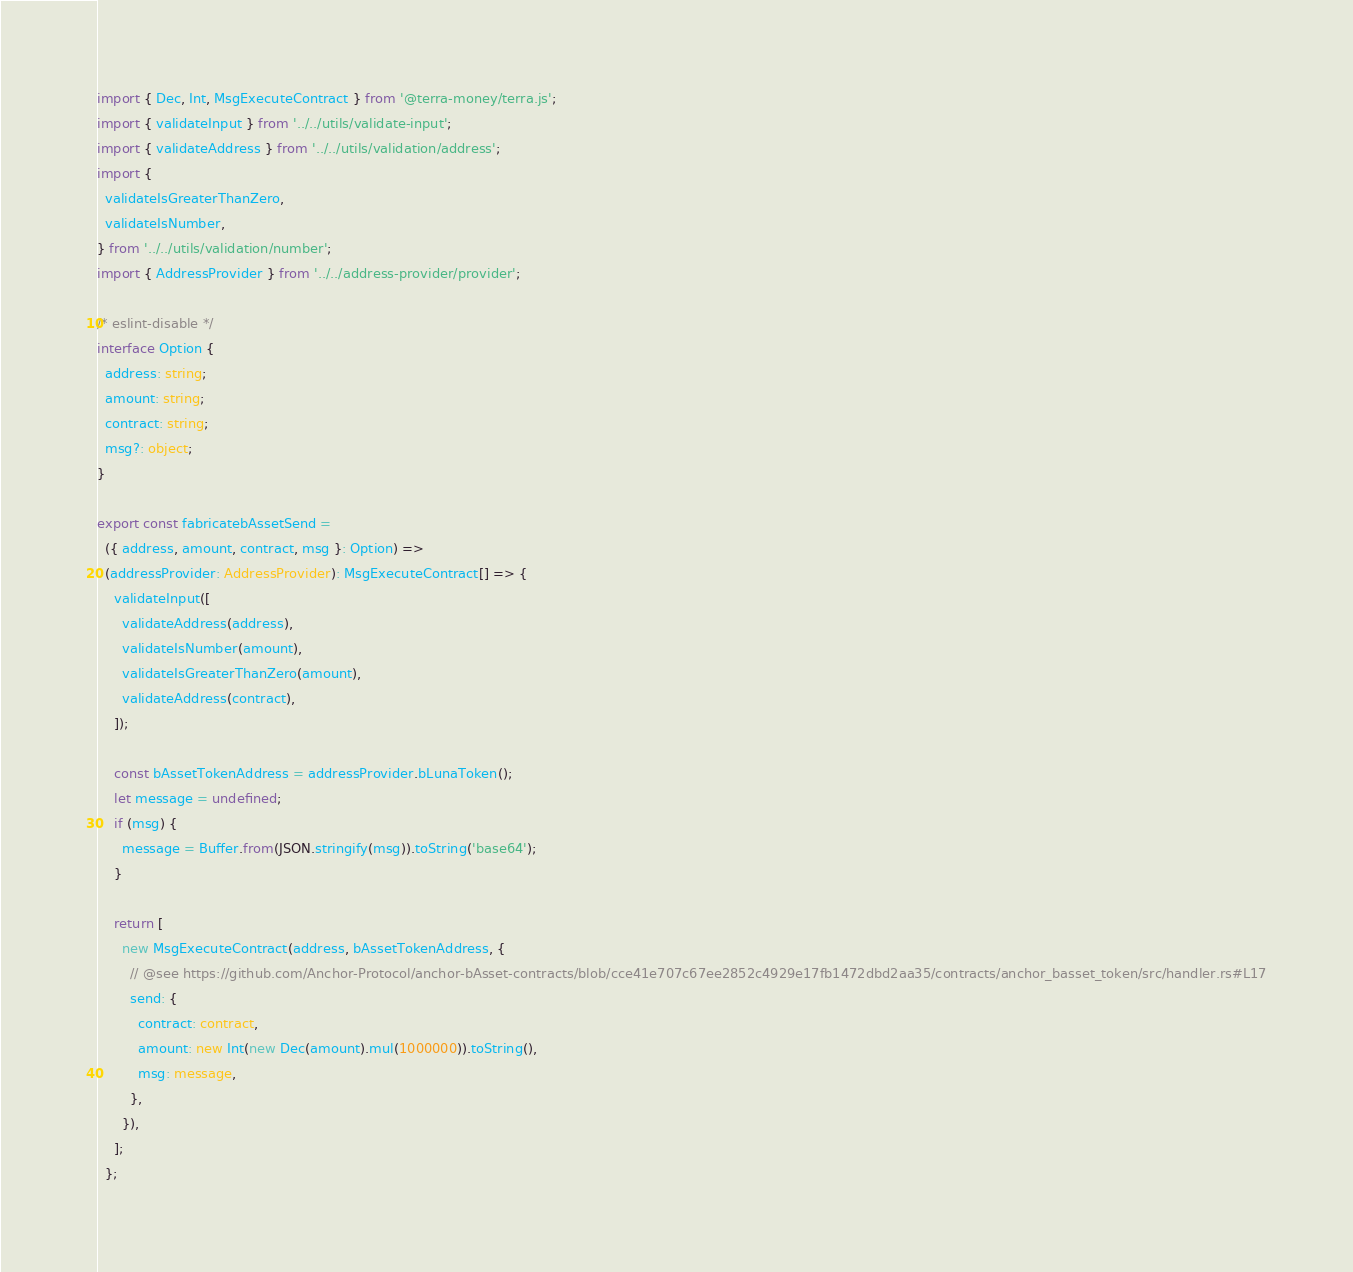Convert code to text. <code><loc_0><loc_0><loc_500><loc_500><_TypeScript_>import { Dec, Int, MsgExecuteContract } from '@terra-money/terra.js';
import { validateInput } from '../../utils/validate-input';
import { validateAddress } from '../../utils/validation/address';
import {
  validateIsGreaterThanZero,
  validateIsNumber,
} from '../../utils/validation/number';
import { AddressProvider } from '../../address-provider/provider';

/* eslint-disable */
interface Option {
  address: string;
  amount: string;
  contract: string;
  msg?: object;
}

export const fabricatebAssetSend =
  ({ address, amount, contract, msg }: Option) =>
  (addressProvider: AddressProvider): MsgExecuteContract[] => {
    validateInput([
      validateAddress(address),
      validateIsNumber(amount),
      validateIsGreaterThanZero(amount),
      validateAddress(contract),
    ]);

    const bAssetTokenAddress = addressProvider.bLunaToken();
    let message = undefined;
    if (msg) {
      message = Buffer.from(JSON.stringify(msg)).toString('base64');
    }

    return [
      new MsgExecuteContract(address, bAssetTokenAddress, {
        // @see https://github.com/Anchor-Protocol/anchor-bAsset-contracts/blob/cce41e707c67ee2852c4929e17fb1472dbd2aa35/contracts/anchor_basset_token/src/handler.rs#L17
        send: {
          contract: contract,
          amount: new Int(new Dec(amount).mul(1000000)).toString(),
          msg: message,
        },
      }),
    ];
  };
</code> 